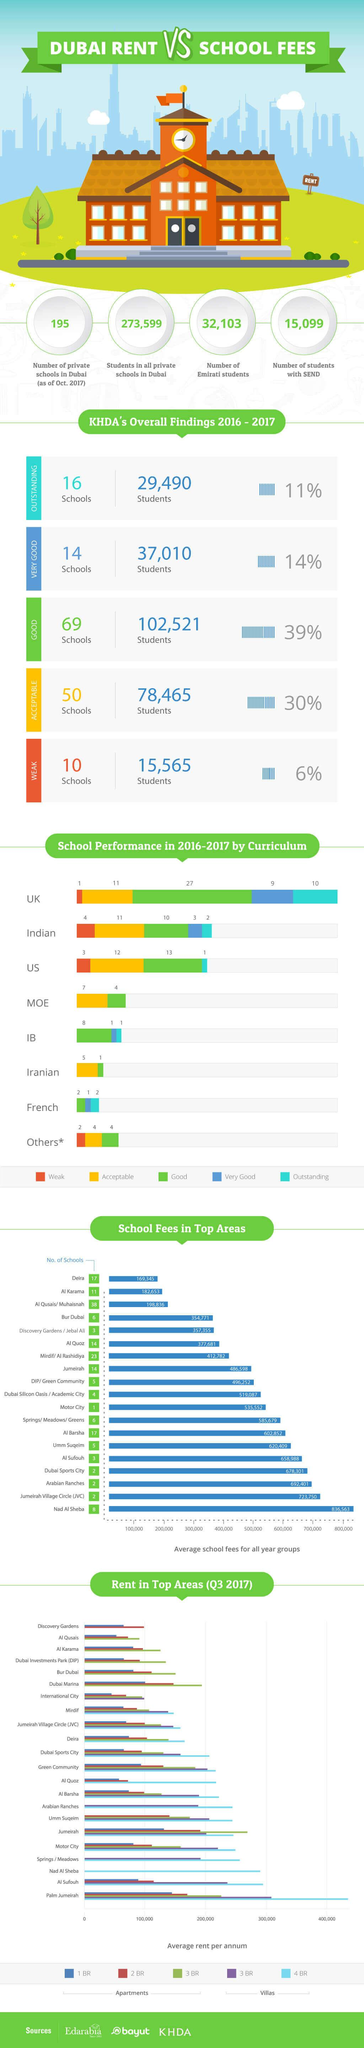List a handful of essential elements in this visual. The number of outstanding schools in Dubai during the 2016-2017 period according to the Knowledge and Human Development Authority (KHDA) was 16. In Q3 2017, Palm Jumeirah was the area in Dubai where 4-bedroom villas cost an average rent of above 400,000 AED per annum. Dubai is a city with many schools, but in the area of Motor City, there are fewer schools compared to other areas. Al Qusais and Muhaisnah are the areas in Dubai that have the highest number of schools. During the 2016-2017 academic year, it is estimated that approximately 2% of Indian schools demonstrated exceptional performance in their curriculum. 